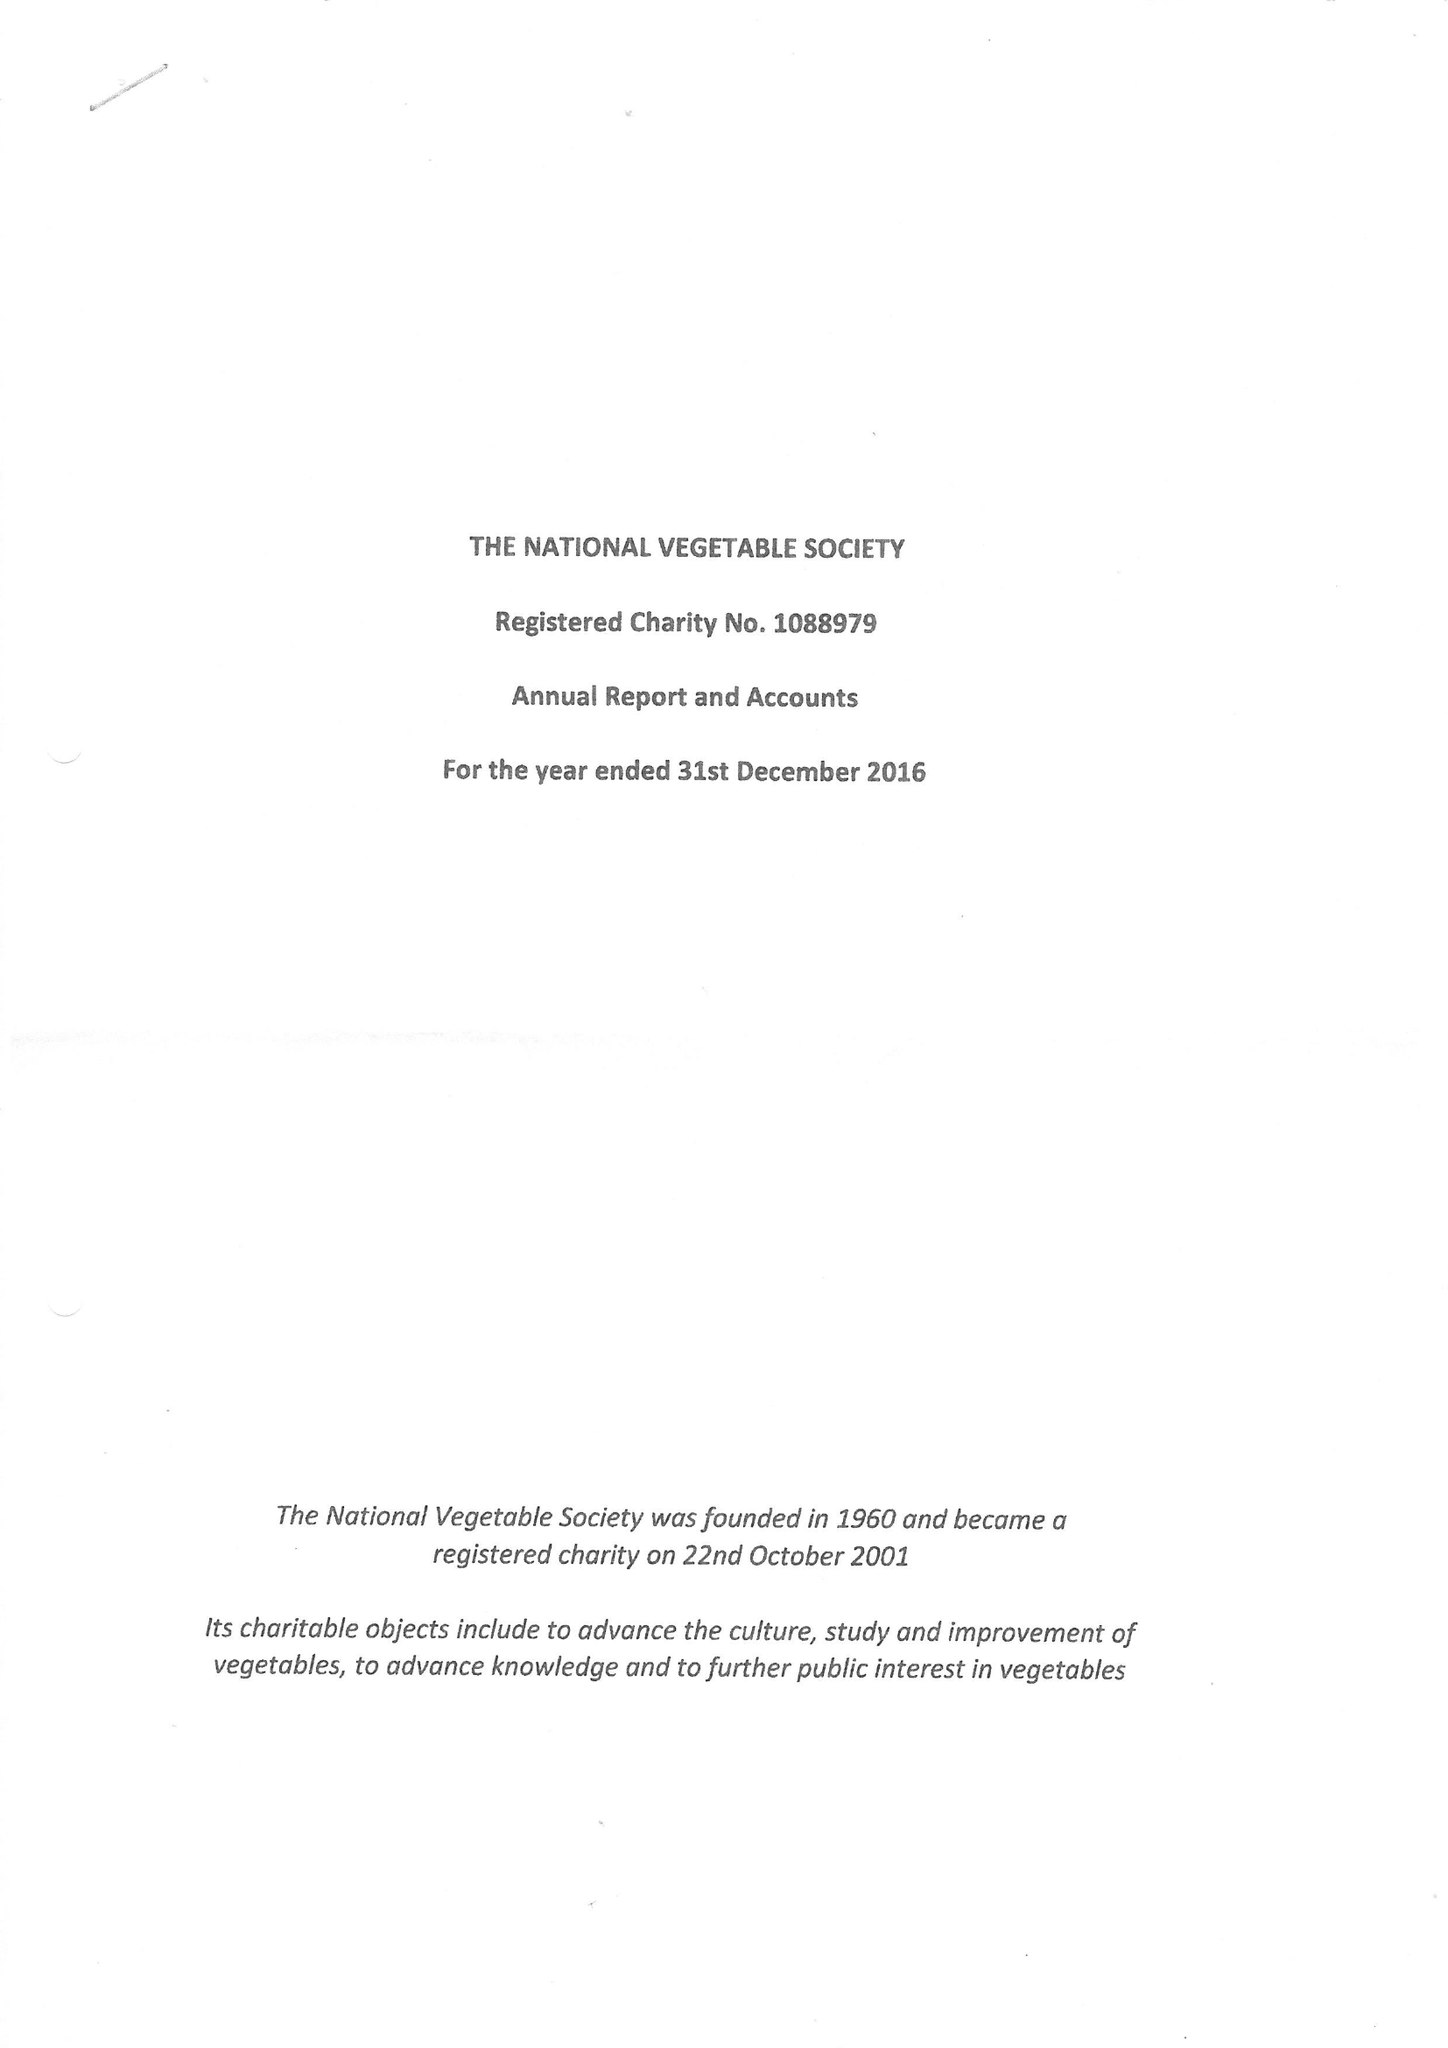What is the value for the charity_name?
Answer the question using a single word or phrase. The National Vegetable Society 